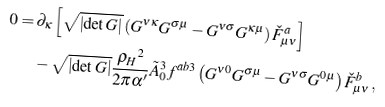<formula> <loc_0><loc_0><loc_500><loc_500>0 = \, & \partial _ { \kappa } \left [ \sqrt { \left | \det G \right | } \left ( G ^ { \nu \kappa } G ^ { \sigma \mu } - G ^ { \nu \sigma } G ^ { \kappa \mu } \right ) \check { F } _ { \mu \nu } ^ { a } \right ] \\ & - \sqrt { \left | \det G \right | } \frac { { \varrho _ { H } } ^ { 2 } } { 2 \pi \alpha ^ { \prime } } \tilde { A } _ { 0 } ^ { 3 } f ^ { a b 3 } \left ( G ^ { \nu 0 } G ^ { \sigma \mu } - G ^ { \nu \sigma } G ^ { 0 \mu } \right ) \check { F } _ { \mu \nu } ^ { b } \, ,</formula> 